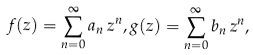Convert formula to latex. <formula><loc_0><loc_0><loc_500><loc_500>f ( z ) = \sum _ { n = 0 } ^ { \infty } a _ { n } \, z ^ { n } , g ( z ) = \sum _ { n = 0 } ^ { \infty } b _ { n } \, z ^ { n } ,</formula> 